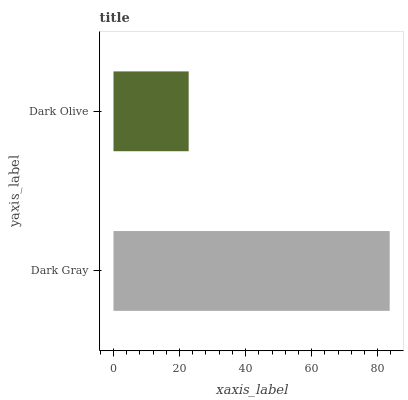Is Dark Olive the minimum?
Answer yes or no. Yes. Is Dark Gray the maximum?
Answer yes or no. Yes. Is Dark Olive the maximum?
Answer yes or no. No. Is Dark Gray greater than Dark Olive?
Answer yes or no. Yes. Is Dark Olive less than Dark Gray?
Answer yes or no. Yes. Is Dark Olive greater than Dark Gray?
Answer yes or no. No. Is Dark Gray less than Dark Olive?
Answer yes or no. No. Is Dark Gray the high median?
Answer yes or no. Yes. Is Dark Olive the low median?
Answer yes or no. Yes. Is Dark Olive the high median?
Answer yes or no. No. Is Dark Gray the low median?
Answer yes or no. No. 